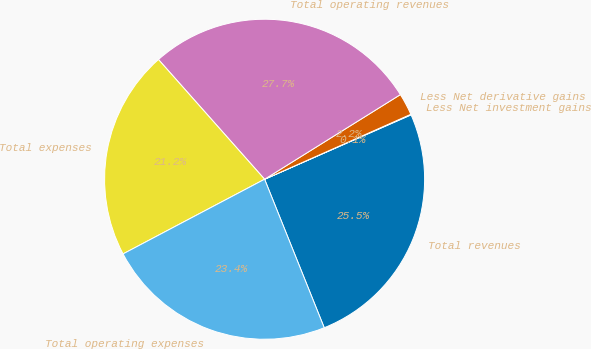<chart> <loc_0><loc_0><loc_500><loc_500><pie_chart><fcel>Total revenues<fcel>Less Net investment gains<fcel>Less Net derivative gains<fcel>Total operating revenues<fcel>Total expenses<fcel>Total operating expenses<nl><fcel>25.51%<fcel>0.06%<fcel>2.22%<fcel>27.67%<fcel>21.18%<fcel>23.35%<nl></chart> 